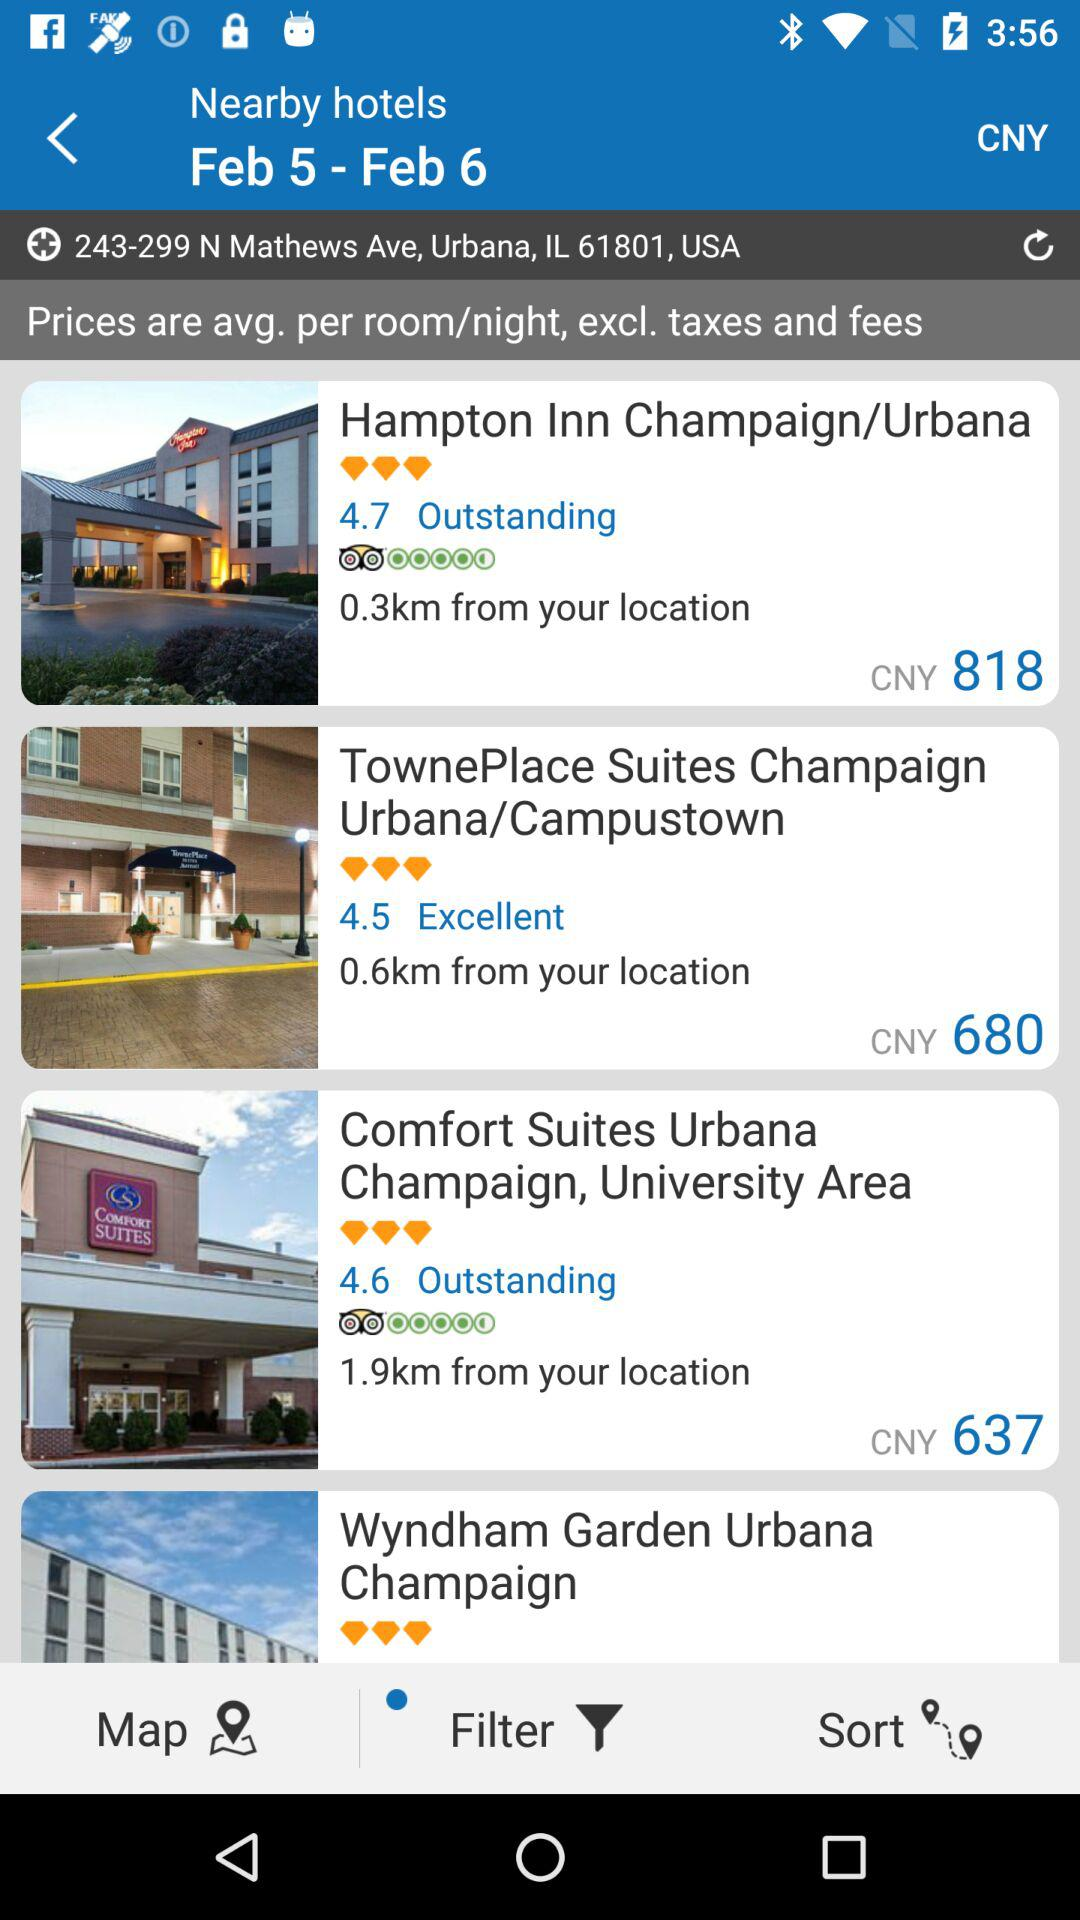What is the currency of the prices? The currency of the prices is CNY. 